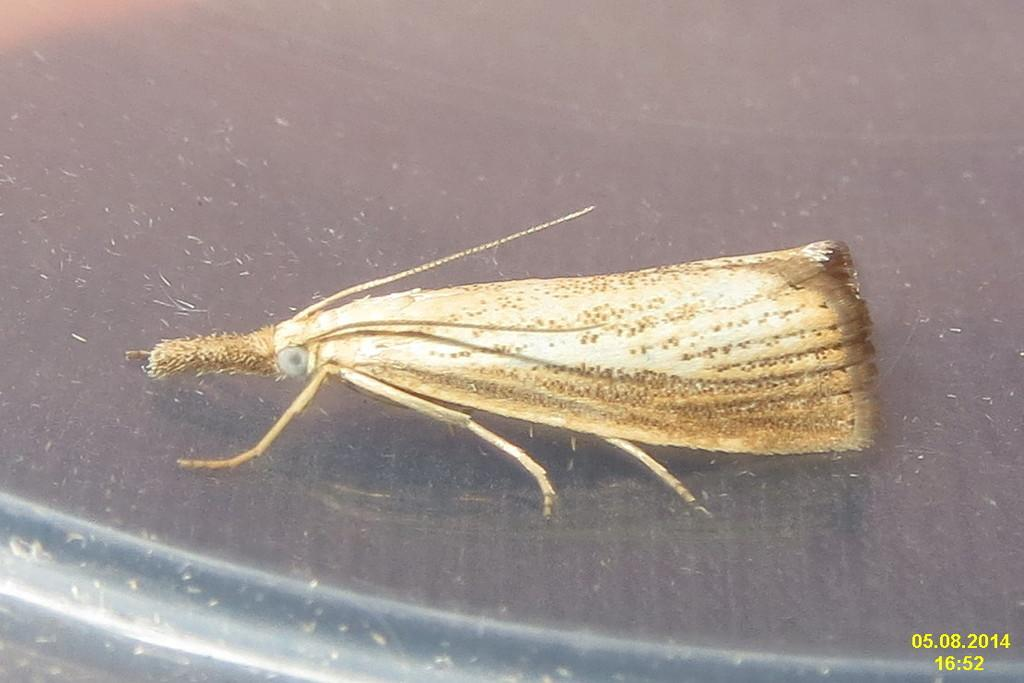What type of creature can be seen in the image? There is an insect in the image. Where is the insect located? The insect is on an object. Can you describe any additional features of the image? There is a watermark on the image. How many snails can be seen in the image? There are no snails present in the image; it features an insect on an object. What type of lumber is used to create the object in the image? There is no information about the object's material in the image, so it cannot be determined. 